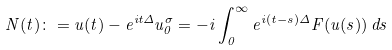<formula> <loc_0><loc_0><loc_500><loc_500>N ( t ) \colon = u ( t ) - e ^ { i t \Delta } u _ { 0 } ^ { \sigma } = - i \int _ { 0 } ^ { \infty } e ^ { i ( t - s ) \Delta } F ( u ( s ) ) \, d s</formula> 